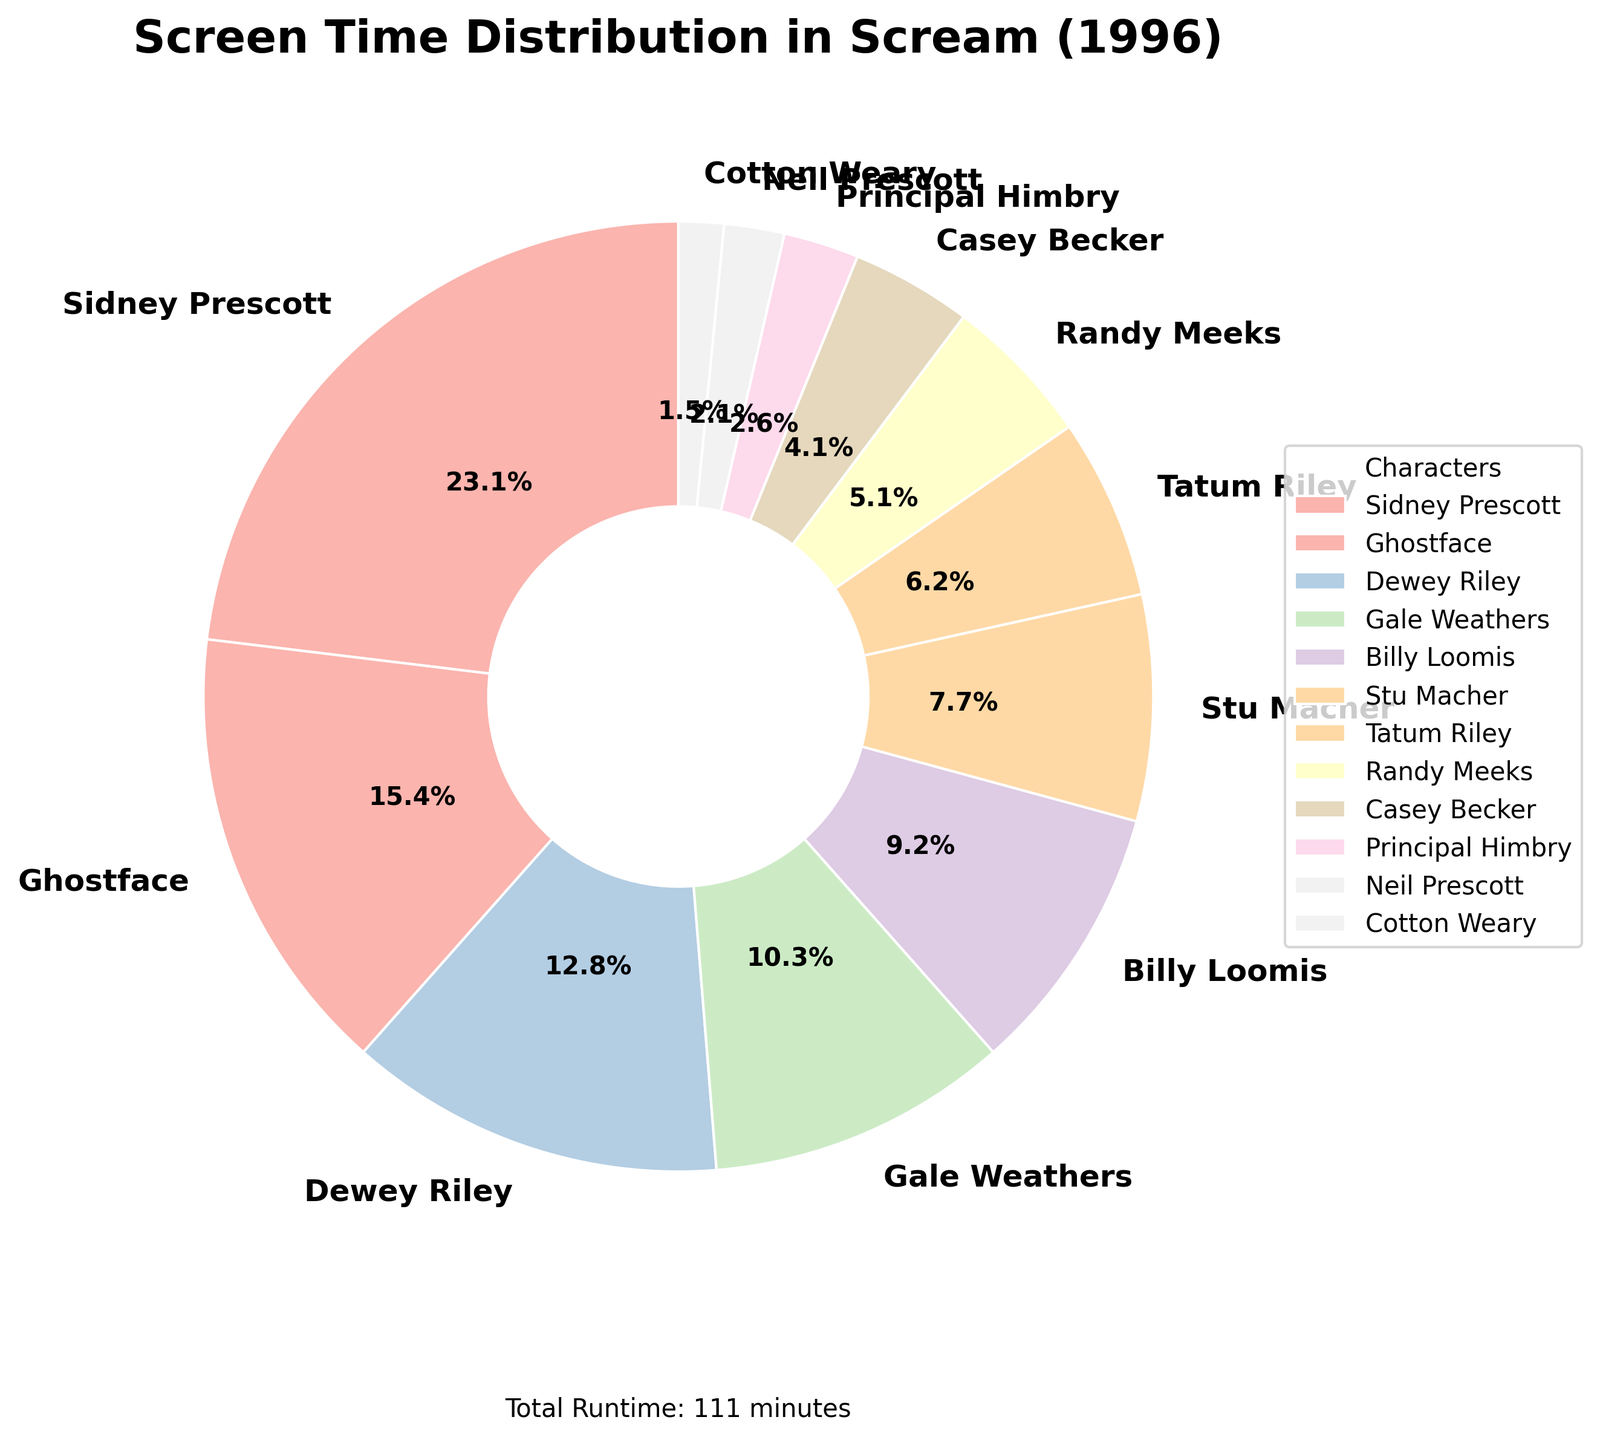What percentage of screen time does Sidney Prescott have? Sidney Prescott has 45 minutes of screen time. To find the percentage, divide her screen time by the total screen time of 111 minutes and multiply by 100. Calculation: (45/111) * 100 ≈ 40.5%
Answer: 40.5% Who has more screen time, Dewey Riley or Gale Weathers? Dewey Riley has 25 minutes, and Gale Weathers has 20 minutes. Comparing these values, Dewey Riley has more screen time.
Answer: Dewey Riley Which character has the least screen time? The character with the least screen time is Cotton Weary, with 3 minutes as shown in the smallest wedge of the pie chart.
Answer: Cotton Weary How much total screen time do Ghostface and Billy Loomis have combined? Ghostface has 30 minutes of screen time, and Billy Loomis has 18 minutes. The total screen time combined is 30 + 18 = 48 minutes.
Answer: 48 minutes What is the difference in screen time between Stu Macher and Tatum Riley? Stu Macher has 15 minutes of screen time, and Tatum Riley has 12 minutes. The difference is 15 - 12 = 3 minutes.
Answer: 3 minutes Which character has a larger proportion of screen time, Randy Meeks or Casey Becker? Randy Meeks has 10 minutes of screen time, and Casey Becker has 8 minutes. Comparing these values, Randy Meeks has a larger proportion of screen time.
Answer: Randy Meeks What is the average screen time for the characters with less than 10 minutes of screen time? The characters with less than 10 minutes of screen time are Casey Becker (8), Principal Himbry (5), Neil Prescott (4), and Cotton Weary (3). Their total screen time is 8 + 5 + 4 + 3 = 20 minutes. There are 4 characters, so the average is 20/4 = 5 minutes.
Answer: 5 minutes Compare the screen time of the two characters with 'Prescott' in their names. Who has more? Sidney Prescott has 45 minutes of screen time, and Neil Prescott has 4 minutes. Sidney Prescott has significantly more screen time.
Answer: Sidney Prescott How many characters have more than 15 minutes of screen time? The characters with more than 15 minutes of screen time are Sidney Prescott (45), Ghostface (30), Dewey Riley (25), and Gale Weathers (20). Counting these, there are 4 characters.
Answer: 4 characters What's the combined screen time of the three characters with the least screen time? The three characters with the least screen time are Neil Prescott (4), Cotton Weary (3), and Principal Himbry (5). Combined, their screen time is 4 + 3 + 5 = 12 minutes.
Answer: 12 minutes 